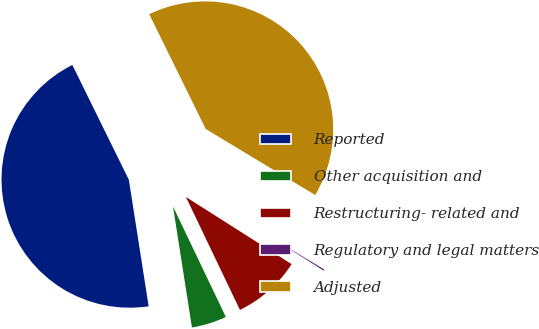Convert chart to OTSL. <chart><loc_0><loc_0><loc_500><loc_500><pie_chart><fcel>Reported<fcel>Other acquisition and<fcel>Restructuring- related and<fcel>Regulatory and legal matters<fcel>Adjusted<nl><fcel>45.19%<fcel>4.63%<fcel>8.89%<fcel>0.37%<fcel>40.92%<nl></chart> 